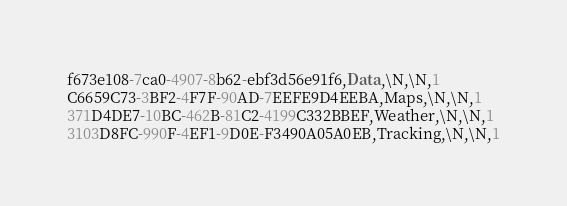<code> <loc_0><loc_0><loc_500><loc_500><_SQL_>f673e108-7ca0-4907-8b62-ebf3d56e91f6,Data,\N,\N,1
C6659C73-3BF2-4F7F-90AD-7EEFE9D4EEBA,Maps,\N,\N,1
371D4DE7-10BC-462B-81C2-4199C332BBEF,Weather,\N,\N,1
3103D8FC-990F-4EF1-9D0E-F3490A05A0EB,Tracking,\N,\N,1</code> 